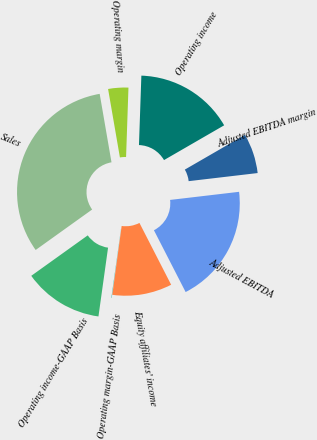Convert chart to OTSL. <chart><loc_0><loc_0><loc_500><loc_500><pie_chart><fcel>Sales<fcel>Operating income-GAAP Basis<fcel>Operating margin-GAAP Basis<fcel>Equity affiliates' income<fcel>Adjusted EBITDA<fcel>Adjusted EBITDA margin<fcel>Operating income<fcel>Operating margin<nl><fcel>32.17%<fcel>12.9%<fcel>0.06%<fcel>9.69%<fcel>19.32%<fcel>6.48%<fcel>16.11%<fcel>3.27%<nl></chart> 